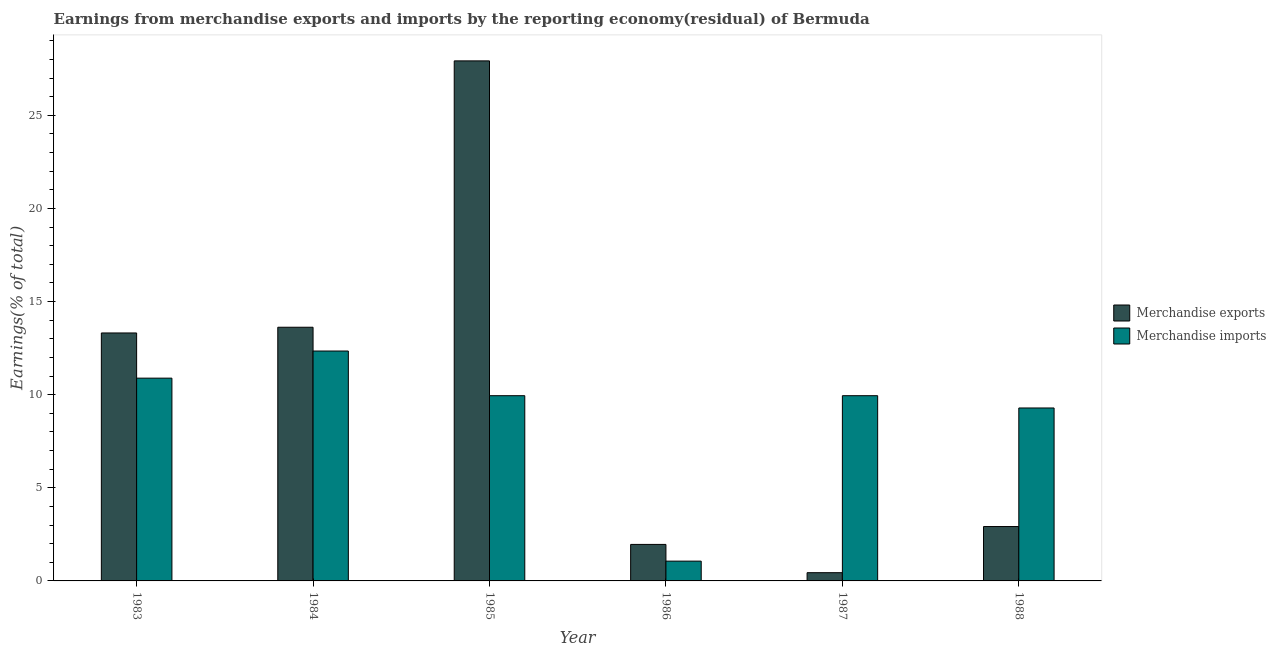How many different coloured bars are there?
Your answer should be very brief. 2. How many groups of bars are there?
Make the answer very short. 6. Are the number of bars per tick equal to the number of legend labels?
Make the answer very short. Yes. Are the number of bars on each tick of the X-axis equal?
Provide a short and direct response. Yes. What is the label of the 1st group of bars from the left?
Ensure brevity in your answer.  1983. What is the earnings from merchandise imports in 1988?
Your response must be concise. 9.29. Across all years, what is the maximum earnings from merchandise exports?
Provide a short and direct response. 27.92. Across all years, what is the minimum earnings from merchandise exports?
Your answer should be very brief. 0.44. In which year was the earnings from merchandise imports maximum?
Ensure brevity in your answer.  1984. In which year was the earnings from merchandise exports minimum?
Provide a succinct answer. 1987. What is the total earnings from merchandise exports in the graph?
Ensure brevity in your answer.  60.18. What is the difference between the earnings from merchandise imports in 1984 and that in 1988?
Ensure brevity in your answer.  3.06. What is the difference between the earnings from merchandise exports in 1988 and the earnings from merchandise imports in 1984?
Your answer should be very brief. -10.7. What is the average earnings from merchandise imports per year?
Your answer should be compact. 8.91. In how many years, is the earnings from merchandise imports greater than 26 %?
Keep it short and to the point. 0. What is the ratio of the earnings from merchandise exports in 1983 to that in 1984?
Your answer should be compact. 0.98. What is the difference between the highest and the second highest earnings from merchandise exports?
Provide a succinct answer. 14.3. What is the difference between the highest and the lowest earnings from merchandise imports?
Ensure brevity in your answer.  11.28. How many bars are there?
Provide a short and direct response. 12. Are all the bars in the graph horizontal?
Provide a succinct answer. No. How many years are there in the graph?
Keep it short and to the point. 6. Where does the legend appear in the graph?
Your answer should be very brief. Center right. How many legend labels are there?
Give a very brief answer. 2. What is the title of the graph?
Offer a very short reply. Earnings from merchandise exports and imports by the reporting economy(residual) of Bermuda. Does "Highest 20% of population" appear as one of the legend labels in the graph?
Make the answer very short. No. What is the label or title of the X-axis?
Keep it short and to the point. Year. What is the label or title of the Y-axis?
Provide a short and direct response. Earnings(% of total). What is the Earnings(% of total) of Merchandise exports in 1983?
Keep it short and to the point. 13.31. What is the Earnings(% of total) in Merchandise imports in 1983?
Give a very brief answer. 10.89. What is the Earnings(% of total) in Merchandise exports in 1984?
Make the answer very short. 13.62. What is the Earnings(% of total) in Merchandise imports in 1984?
Your response must be concise. 12.34. What is the Earnings(% of total) in Merchandise exports in 1985?
Your response must be concise. 27.92. What is the Earnings(% of total) in Merchandise imports in 1985?
Your response must be concise. 9.94. What is the Earnings(% of total) of Merchandise exports in 1986?
Your answer should be compact. 1.96. What is the Earnings(% of total) of Merchandise imports in 1986?
Offer a very short reply. 1.06. What is the Earnings(% of total) in Merchandise exports in 1987?
Your answer should be compact. 0.44. What is the Earnings(% of total) of Merchandise imports in 1987?
Your answer should be compact. 9.94. What is the Earnings(% of total) in Merchandise exports in 1988?
Your response must be concise. 2.92. What is the Earnings(% of total) in Merchandise imports in 1988?
Ensure brevity in your answer.  9.29. Across all years, what is the maximum Earnings(% of total) of Merchandise exports?
Offer a very short reply. 27.92. Across all years, what is the maximum Earnings(% of total) of Merchandise imports?
Provide a short and direct response. 12.34. Across all years, what is the minimum Earnings(% of total) in Merchandise exports?
Your answer should be compact. 0.44. Across all years, what is the minimum Earnings(% of total) of Merchandise imports?
Offer a very short reply. 1.06. What is the total Earnings(% of total) of Merchandise exports in the graph?
Ensure brevity in your answer.  60.18. What is the total Earnings(% of total) in Merchandise imports in the graph?
Your answer should be compact. 53.47. What is the difference between the Earnings(% of total) in Merchandise exports in 1983 and that in 1984?
Provide a succinct answer. -0.31. What is the difference between the Earnings(% of total) in Merchandise imports in 1983 and that in 1984?
Keep it short and to the point. -1.46. What is the difference between the Earnings(% of total) in Merchandise exports in 1983 and that in 1985?
Your answer should be very brief. -14.61. What is the difference between the Earnings(% of total) of Merchandise imports in 1983 and that in 1985?
Your answer should be very brief. 0.94. What is the difference between the Earnings(% of total) in Merchandise exports in 1983 and that in 1986?
Make the answer very short. 11.35. What is the difference between the Earnings(% of total) in Merchandise imports in 1983 and that in 1986?
Your response must be concise. 9.82. What is the difference between the Earnings(% of total) of Merchandise exports in 1983 and that in 1987?
Your answer should be very brief. 12.87. What is the difference between the Earnings(% of total) in Merchandise imports in 1983 and that in 1987?
Offer a terse response. 0.94. What is the difference between the Earnings(% of total) of Merchandise exports in 1983 and that in 1988?
Offer a terse response. 10.39. What is the difference between the Earnings(% of total) of Merchandise imports in 1983 and that in 1988?
Your response must be concise. 1.6. What is the difference between the Earnings(% of total) of Merchandise exports in 1984 and that in 1985?
Your response must be concise. -14.3. What is the difference between the Earnings(% of total) in Merchandise imports in 1984 and that in 1985?
Your answer should be compact. 2.4. What is the difference between the Earnings(% of total) of Merchandise exports in 1984 and that in 1986?
Your answer should be very brief. 11.66. What is the difference between the Earnings(% of total) of Merchandise imports in 1984 and that in 1986?
Provide a short and direct response. 11.28. What is the difference between the Earnings(% of total) of Merchandise exports in 1984 and that in 1987?
Give a very brief answer. 13.18. What is the difference between the Earnings(% of total) of Merchandise imports in 1984 and that in 1987?
Make the answer very short. 2.4. What is the difference between the Earnings(% of total) of Merchandise exports in 1984 and that in 1988?
Make the answer very short. 10.7. What is the difference between the Earnings(% of total) in Merchandise imports in 1984 and that in 1988?
Offer a terse response. 3.06. What is the difference between the Earnings(% of total) in Merchandise exports in 1985 and that in 1986?
Keep it short and to the point. 25.96. What is the difference between the Earnings(% of total) in Merchandise imports in 1985 and that in 1986?
Give a very brief answer. 8.88. What is the difference between the Earnings(% of total) of Merchandise exports in 1985 and that in 1987?
Your answer should be very brief. 27.48. What is the difference between the Earnings(% of total) of Merchandise exports in 1985 and that in 1988?
Offer a terse response. 25. What is the difference between the Earnings(% of total) of Merchandise imports in 1985 and that in 1988?
Ensure brevity in your answer.  0.66. What is the difference between the Earnings(% of total) of Merchandise exports in 1986 and that in 1987?
Give a very brief answer. 1.52. What is the difference between the Earnings(% of total) in Merchandise imports in 1986 and that in 1987?
Your response must be concise. -8.88. What is the difference between the Earnings(% of total) of Merchandise exports in 1986 and that in 1988?
Your response must be concise. -0.96. What is the difference between the Earnings(% of total) of Merchandise imports in 1986 and that in 1988?
Make the answer very short. -8.22. What is the difference between the Earnings(% of total) in Merchandise exports in 1987 and that in 1988?
Keep it short and to the point. -2.48. What is the difference between the Earnings(% of total) of Merchandise imports in 1987 and that in 1988?
Ensure brevity in your answer.  0.66. What is the difference between the Earnings(% of total) in Merchandise exports in 1983 and the Earnings(% of total) in Merchandise imports in 1984?
Ensure brevity in your answer.  0.97. What is the difference between the Earnings(% of total) of Merchandise exports in 1983 and the Earnings(% of total) of Merchandise imports in 1985?
Your answer should be compact. 3.37. What is the difference between the Earnings(% of total) of Merchandise exports in 1983 and the Earnings(% of total) of Merchandise imports in 1986?
Provide a short and direct response. 12.25. What is the difference between the Earnings(% of total) of Merchandise exports in 1983 and the Earnings(% of total) of Merchandise imports in 1987?
Make the answer very short. 3.37. What is the difference between the Earnings(% of total) of Merchandise exports in 1983 and the Earnings(% of total) of Merchandise imports in 1988?
Keep it short and to the point. 4.03. What is the difference between the Earnings(% of total) in Merchandise exports in 1984 and the Earnings(% of total) in Merchandise imports in 1985?
Keep it short and to the point. 3.68. What is the difference between the Earnings(% of total) in Merchandise exports in 1984 and the Earnings(% of total) in Merchandise imports in 1986?
Your response must be concise. 12.56. What is the difference between the Earnings(% of total) of Merchandise exports in 1984 and the Earnings(% of total) of Merchandise imports in 1987?
Keep it short and to the point. 3.68. What is the difference between the Earnings(% of total) of Merchandise exports in 1984 and the Earnings(% of total) of Merchandise imports in 1988?
Offer a very short reply. 4.33. What is the difference between the Earnings(% of total) of Merchandise exports in 1985 and the Earnings(% of total) of Merchandise imports in 1986?
Keep it short and to the point. 26.86. What is the difference between the Earnings(% of total) of Merchandise exports in 1985 and the Earnings(% of total) of Merchandise imports in 1987?
Your answer should be very brief. 17.98. What is the difference between the Earnings(% of total) in Merchandise exports in 1985 and the Earnings(% of total) in Merchandise imports in 1988?
Make the answer very short. 18.64. What is the difference between the Earnings(% of total) in Merchandise exports in 1986 and the Earnings(% of total) in Merchandise imports in 1987?
Keep it short and to the point. -7.98. What is the difference between the Earnings(% of total) of Merchandise exports in 1986 and the Earnings(% of total) of Merchandise imports in 1988?
Offer a very short reply. -7.33. What is the difference between the Earnings(% of total) of Merchandise exports in 1987 and the Earnings(% of total) of Merchandise imports in 1988?
Ensure brevity in your answer.  -8.84. What is the average Earnings(% of total) in Merchandise exports per year?
Make the answer very short. 10.03. What is the average Earnings(% of total) in Merchandise imports per year?
Provide a succinct answer. 8.91. In the year 1983, what is the difference between the Earnings(% of total) in Merchandise exports and Earnings(% of total) in Merchandise imports?
Offer a terse response. 2.43. In the year 1984, what is the difference between the Earnings(% of total) in Merchandise exports and Earnings(% of total) in Merchandise imports?
Offer a very short reply. 1.28. In the year 1985, what is the difference between the Earnings(% of total) in Merchandise exports and Earnings(% of total) in Merchandise imports?
Make the answer very short. 17.98. In the year 1986, what is the difference between the Earnings(% of total) in Merchandise exports and Earnings(% of total) in Merchandise imports?
Provide a succinct answer. 0.9. In the year 1987, what is the difference between the Earnings(% of total) in Merchandise exports and Earnings(% of total) in Merchandise imports?
Your answer should be very brief. -9.5. In the year 1988, what is the difference between the Earnings(% of total) in Merchandise exports and Earnings(% of total) in Merchandise imports?
Provide a succinct answer. -6.37. What is the ratio of the Earnings(% of total) of Merchandise exports in 1983 to that in 1984?
Provide a succinct answer. 0.98. What is the ratio of the Earnings(% of total) in Merchandise imports in 1983 to that in 1984?
Offer a very short reply. 0.88. What is the ratio of the Earnings(% of total) of Merchandise exports in 1983 to that in 1985?
Provide a succinct answer. 0.48. What is the ratio of the Earnings(% of total) in Merchandise imports in 1983 to that in 1985?
Offer a terse response. 1.09. What is the ratio of the Earnings(% of total) in Merchandise exports in 1983 to that in 1986?
Give a very brief answer. 6.79. What is the ratio of the Earnings(% of total) in Merchandise imports in 1983 to that in 1986?
Your response must be concise. 10.25. What is the ratio of the Earnings(% of total) in Merchandise exports in 1983 to that in 1987?
Provide a succinct answer. 30.11. What is the ratio of the Earnings(% of total) of Merchandise imports in 1983 to that in 1987?
Keep it short and to the point. 1.09. What is the ratio of the Earnings(% of total) in Merchandise exports in 1983 to that in 1988?
Ensure brevity in your answer.  4.56. What is the ratio of the Earnings(% of total) of Merchandise imports in 1983 to that in 1988?
Provide a short and direct response. 1.17. What is the ratio of the Earnings(% of total) of Merchandise exports in 1984 to that in 1985?
Ensure brevity in your answer.  0.49. What is the ratio of the Earnings(% of total) in Merchandise imports in 1984 to that in 1985?
Make the answer very short. 1.24. What is the ratio of the Earnings(% of total) in Merchandise exports in 1984 to that in 1986?
Make the answer very short. 6.95. What is the ratio of the Earnings(% of total) of Merchandise imports in 1984 to that in 1986?
Keep it short and to the point. 11.62. What is the ratio of the Earnings(% of total) in Merchandise exports in 1984 to that in 1987?
Your answer should be compact. 30.81. What is the ratio of the Earnings(% of total) of Merchandise imports in 1984 to that in 1987?
Your answer should be very brief. 1.24. What is the ratio of the Earnings(% of total) in Merchandise exports in 1984 to that in 1988?
Give a very brief answer. 4.67. What is the ratio of the Earnings(% of total) of Merchandise imports in 1984 to that in 1988?
Provide a short and direct response. 1.33. What is the ratio of the Earnings(% of total) in Merchandise exports in 1985 to that in 1986?
Ensure brevity in your answer.  14.24. What is the ratio of the Earnings(% of total) of Merchandise imports in 1985 to that in 1986?
Your response must be concise. 9.36. What is the ratio of the Earnings(% of total) in Merchandise exports in 1985 to that in 1987?
Offer a terse response. 63.15. What is the ratio of the Earnings(% of total) in Merchandise imports in 1985 to that in 1987?
Offer a terse response. 1. What is the ratio of the Earnings(% of total) in Merchandise exports in 1985 to that in 1988?
Make the answer very short. 9.56. What is the ratio of the Earnings(% of total) of Merchandise imports in 1985 to that in 1988?
Offer a terse response. 1.07. What is the ratio of the Earnings(% of total) of Merchandise exports in 1986 to that in 1987?
Give a very brief answer. 4.43. What is the ratio of the Earnings(% of total) in Merchandise imports in 1986 to that in 1987?
Offer a terse response. 0.11. What is the ratio of the Earnings(% of total) of Merchandise exports in 1986 to that in 1988?
Your response must be concise. 0.67. What is the ratio of the Earnings(% of total) in Merchandise imports in 1986 to that in 1988?
Offer a very short reply. 0.11. What is the ratio of the Earnings(% of total) of Merchandise exports in 1987 to that in 1988?
Give a very brief answer. 0.15. What is the ratio of the Earnings(% of total) of Merchandise imports in 1987 to that in 1988?
Make the answer very short. 1.07. What is the difference between the highest and the second highest Earnings(% of total) of Merchandise exports?
Offer a very short reply. 14.3. What is the difference between the highest and the second highest Earnings(% of total) of Merchandise imports?
Give a very brief answer. 1.46. What is the difference between the highest and the lowest Earnings(% of total) in Merchandise exports?
Provide a succinct answer. 27.48. What is the difference between the highest and the lowest Earnings(% of total) in Merchandise imports?
Give a very brief answer. 11.28. 